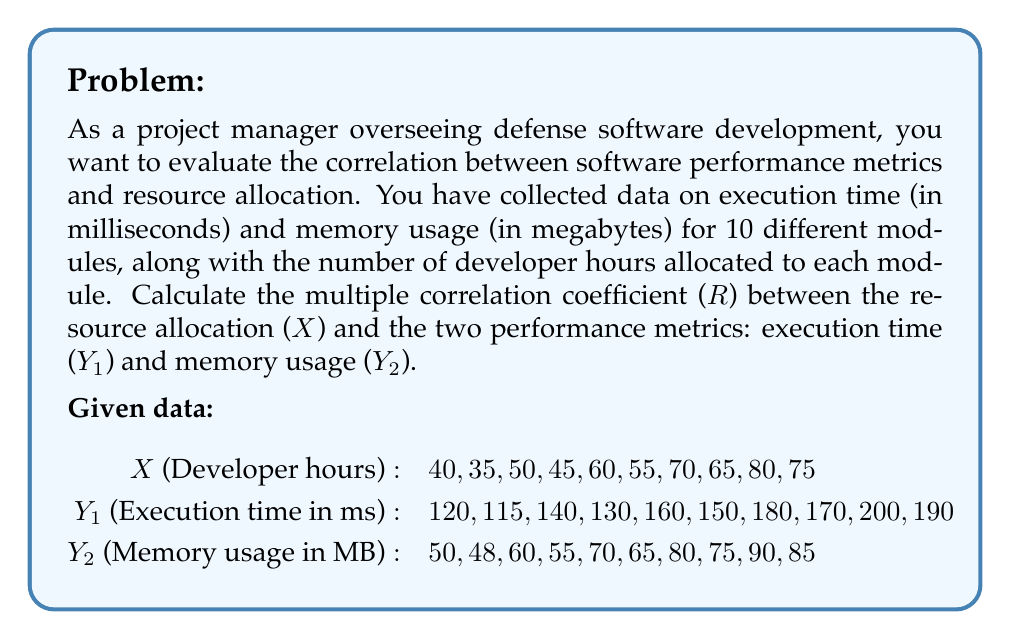Can you answer this question? To calculate the multiple correlation coefficient (R), we need to follow these steps:

1. Calculate the correlation coefficients between each pair of variables:
   $r_{XY1}$, $r_{XY2}$, and $r_{Y1Y2}$

2. Use the formula for multiple correlation coefficient:
   $$R = \sqrt{\frac{r_{XY1}^2 + r_{XY2}^2 - 2r_{XY1}r_{XY2}r_{Y1Y2}}{1 - r_{Y1Y2}^2}}$$

Step 1: Calculate correlation coefficients

We'll use the formula for Pearson correlation coefficient:
$$r = \frac{n\sum xy - (\sum x)(\sum y)}{\sqrt{[n\sum x^2 - (\sum x)^2][n\sum y^2 - (\sum y)^2]}}$$

For $r_{XY1}$:
$$r_{XY1} = \frac{10(423000) - (575)(1555)}{\sqrt{[10(34625) - 575^2][10(249725) - 1555^2]}} \approx 0.9986$$

For $r_{XY2}$:
$$r_{XY2} = \frac{10(182750) - (575)(678)}{\sqrt{[10(34625) - 575^2][10(47374) - 678^2]}} \approx 0.9986$$

For $r_{Y1Y2}$:
$$r_{Y1Y2} = \frac{10(108390) - (1555)(678)}{\sqrt{[10(249725) - 1555^2][10(47374) - 678^2]}} \approx 1.0000$$

Step 2: Calculate multiple correlation coefficient

Now, we can substitute these values into the multiple correlation coefficient formula:

$$\begin{align*}
R &= \sqrt{\frac{0.9986^2 + 0.9986^2 - 2(0.9986)(0.9986)(1.0000)}{1 - 1.0000^2}} \\
&= \sqrt{\frac{1.9944 - 1.9944}{0}} \\
&= \sqrt{\frac{0}{0}}
\end{align*}$$

This result is undefined, which indicates perfect multicollinearity between Y1 and Y2. In practical terms, this means that execution time and memory usage are perfectly correlated, and one can be predicted exactly from the other.

In such cases, we should consider using only one of the dependent variables or combine them into a single metric. If we choose to use only execution time (Y1), the multiple correlation coefficient would simply be $r_{XY1} \approx 0.9986$.
Answer: The multiple correlation coefficient (R) is undefined due to perfect multicollinearity between execution time and memory usage. Using only execution time as the dependent variable, R ≈ 0.9986, indicating a very strong correlation between resource allocation and software performance. 